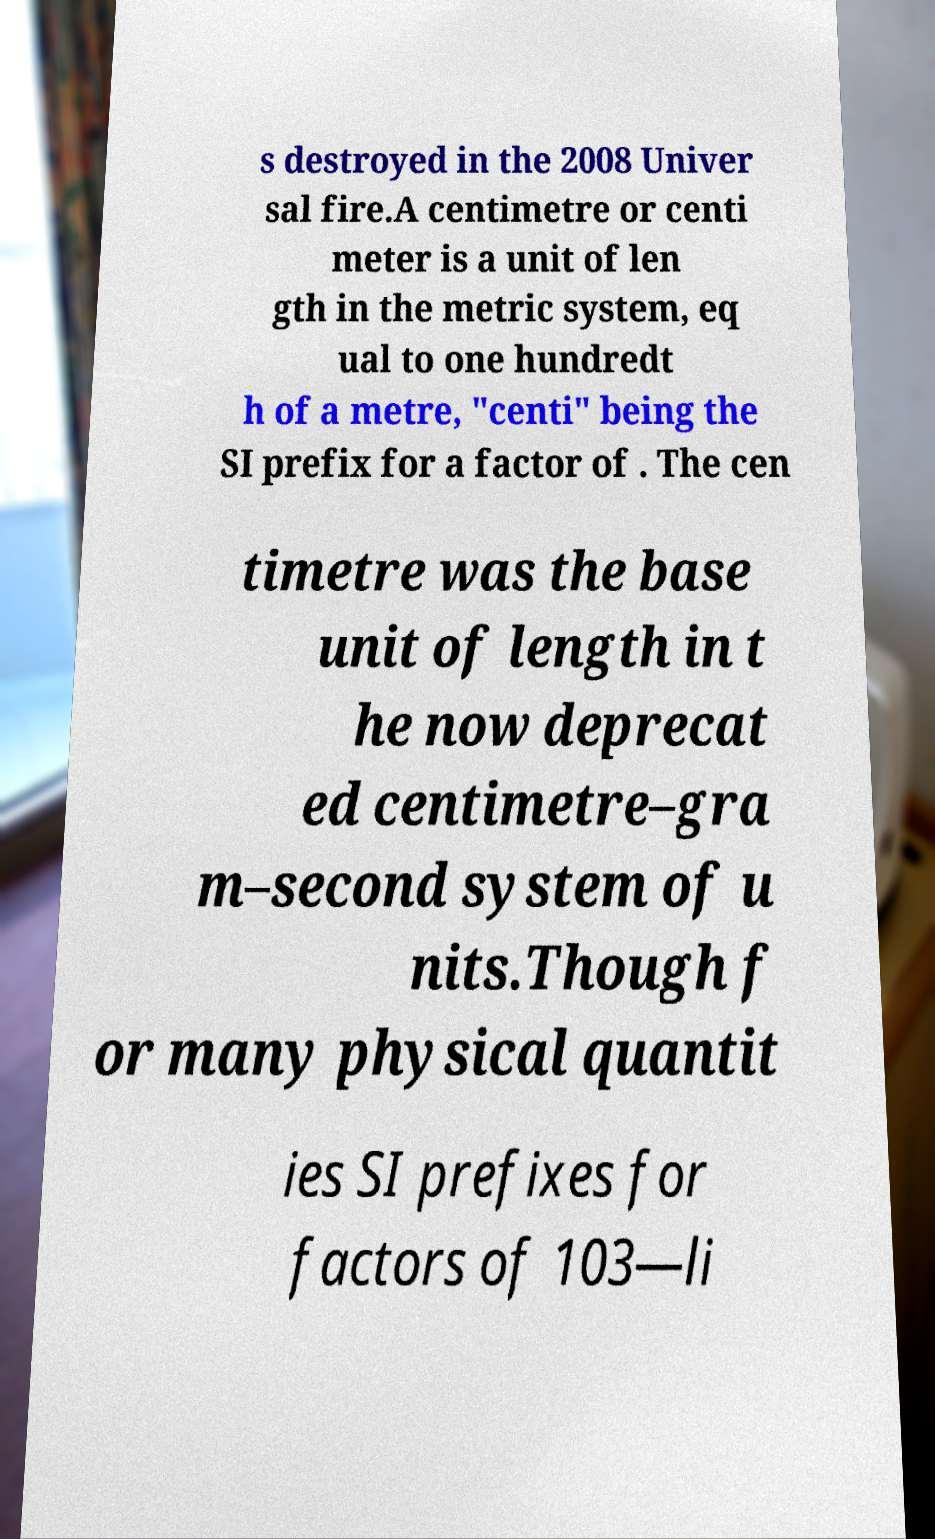Could you assist in decoding the text presented in this image and type it out clearly? s destroyed in the 2008 Univer sal fire.A centimetre or centi meter is a unit of len gth in the metric system, eq ual to one hundredt h of a metre, "centi" being the SI prefix for a factor of . The cen timetre was the base unit of length in t he now deprecat ed centimetre–gra m–second system of u nits.Though f or many physical quantit ies SI prefixes for factors of 103—li 